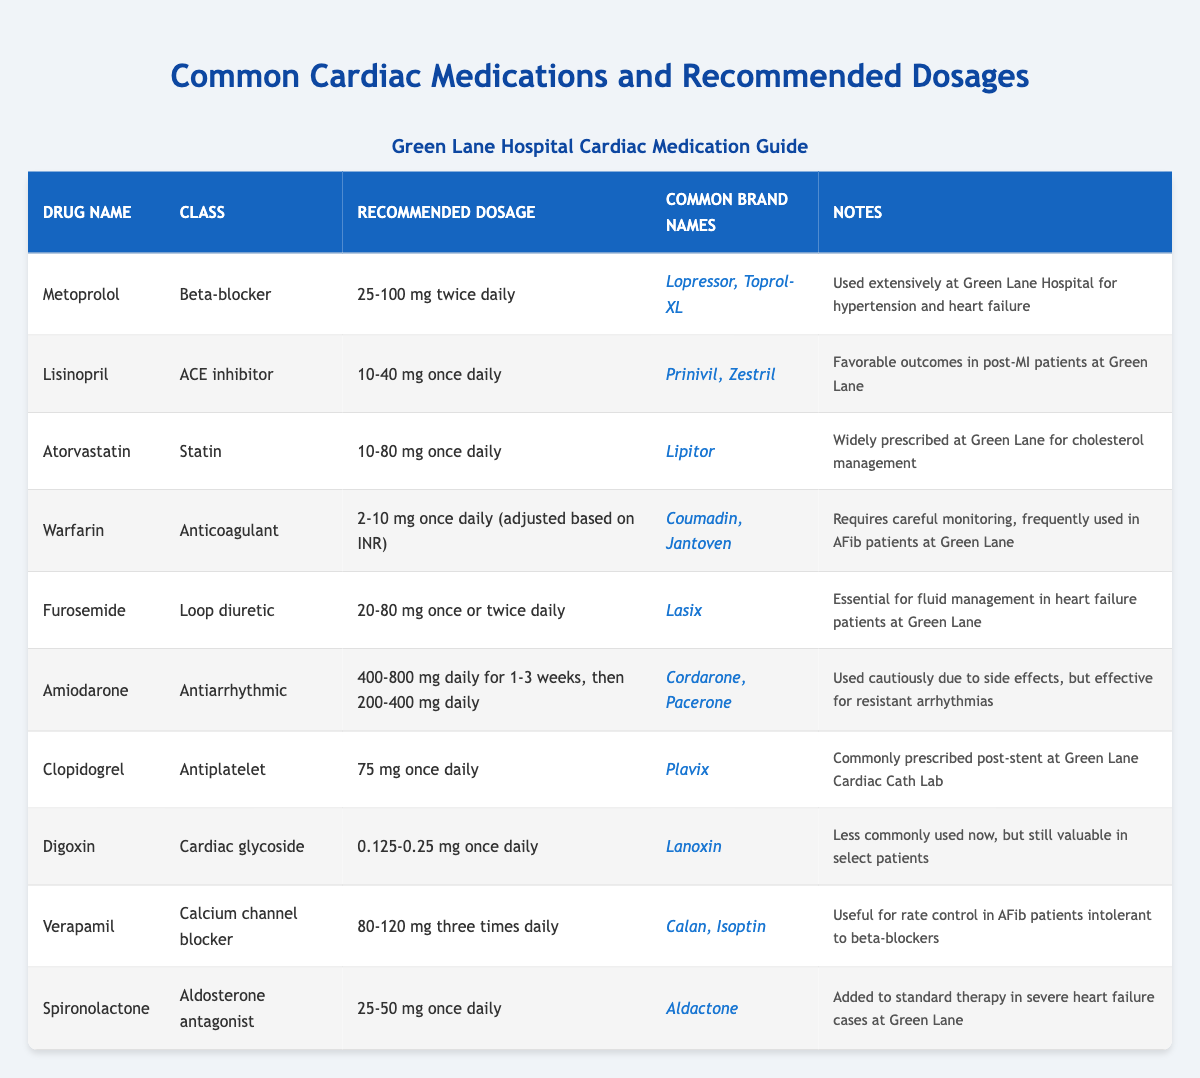What is the recommended dosage for Metoprolol? The table lists the recommended dosage for Metoprolol as "25-100 mg twice daily." This information can be directly found in the "Recommended Dosage" column corresponding to the drug name "Metoprolol."
Answer: 25-100 mg twice daily Which class of medication does Lisinopril belong to? By looking at the table, the class of medication for Lisinopril is specified as "ACE inhibitor" in the "Class" column beside the drug name Lisinopril.
Answer: ACE inhibitor How many cardiac medications have a recommended dosage of once daily? The medications with a recommended dosage of "once daily" are Lisinopril, Atorvastatin, Warfarin, Clopidogrel, and Spironolactone. Counting these, we find that there are 5 medications with this dosage frequency.
Answer: 5 True or False: Amiodarone is a beta-blocker. In the table, Amiodarone is classified under the "Class" column as "Antiarrhythmic," not beta-blocker. Therefore, the statement is false.
Answer: False What is the highest recommended dosage for Furosemide compared to Digoxin? Furosemide has a recommended dosage of "20-80 mg once or twice daily," while Digoxin has a dosage of "0.125-0.25 mg once daily." Here, 80 mg (the upper limit for Furosemide) is significantly higher than 0.25 mg (the upper limit for Digoxin). Thus, Furosemide's highest dosage is higher than that of Digoxin.
Answer: Higher How many common brand names are associated with Warfarin? The table provides two common brand names for Warfarin: "Coumadin" and "Jantoven," as indicated in the "Common Brand Names" column. Thus, there are 2 brand names listed for Warfarin.
Answer: 2 What is the dosage range for Amiodarone and how does it compare to Verapamil? Amiodarone has a recommended dosage range of "400-800 mg daily for 1-3 weeks, then 200-400 mg daily." Verapamil has a dosage of "80-120 mg three times daily." To compare, Amiodarone's upper dosage limit is 800 mg, while Verapamil's maximum in three doses would be 360 mg (120 mg × 3), making Amiodarone's dosage significantly higher.
Answer: Amiodarone's dosage is higher Which drug is used for rate control in AFib patients intolerant to beta-blockers? According to the table, Verapamil is noted as useful for rate control specifically in AFib patients who cannot tolerate beta-blockers. This information is in the "Notes" column next to Verapamil.
Answer: Verapamil 